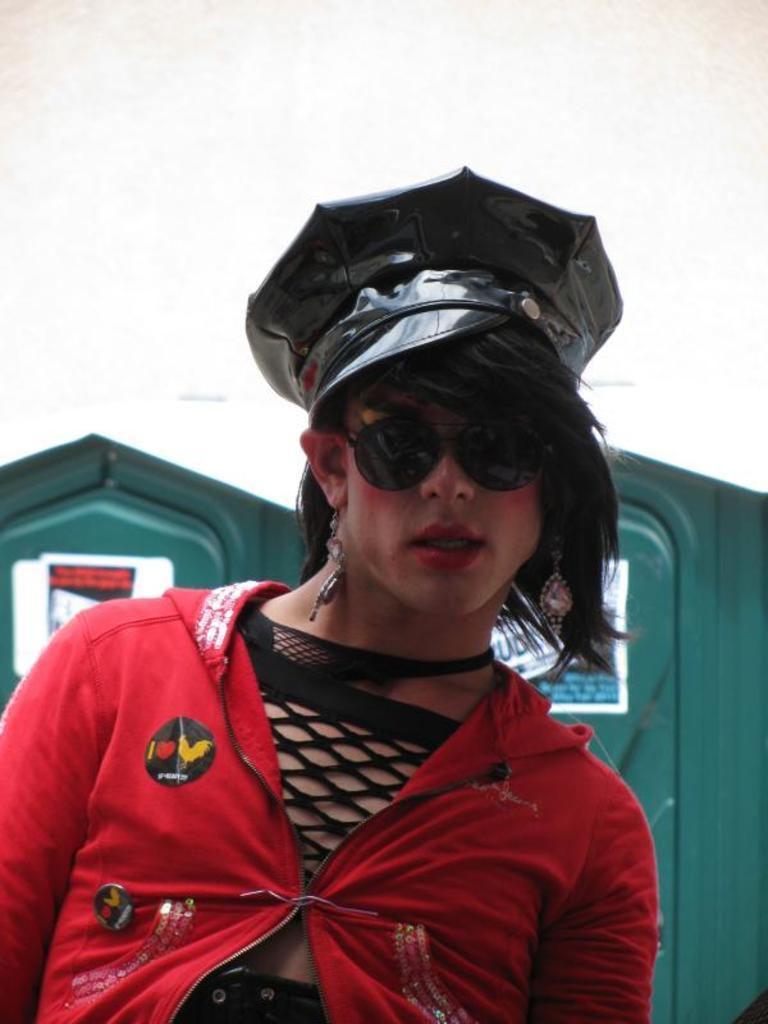What is the main subject of the image? There is a woman standing in the image. What is the woman wearing on her head? The woman is wearing a cap. What can be seen in the background of the image? There is a green color wall in the background of the image. What theory does the woman in the image propose about the smashing of atoms? There is no mention of atoms or any theory in the image; it simply shows a woman standing with a cap on her head and a green wall in the background. 